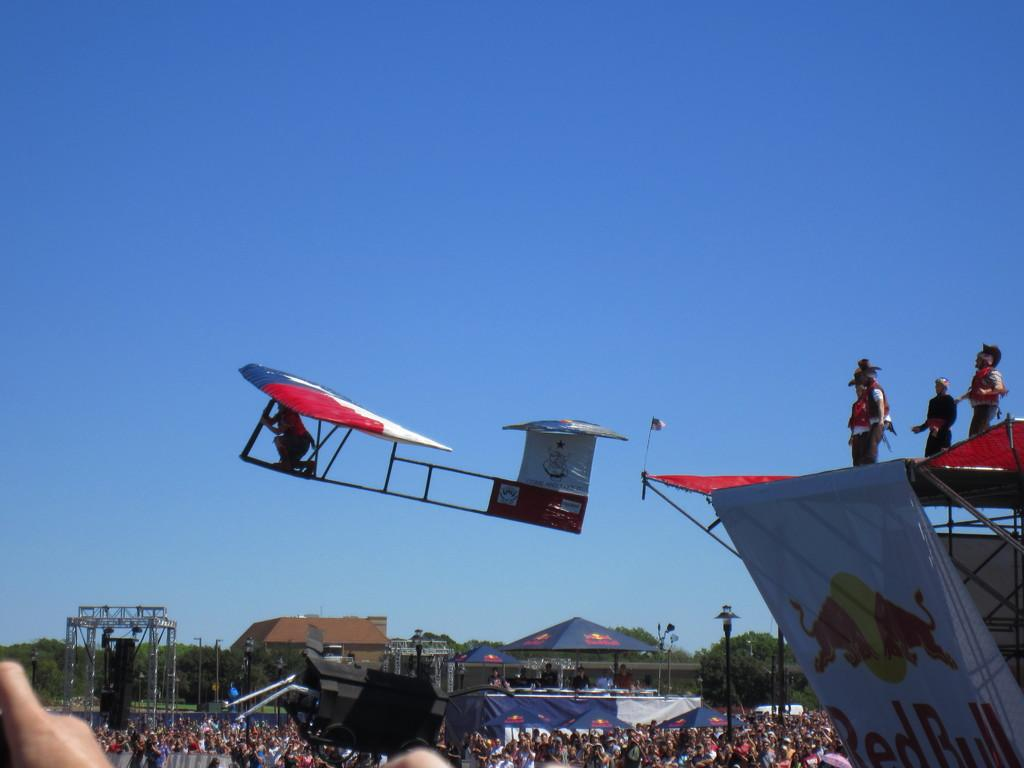Provide a one-sentence caption for the provided image. A few people standing above a banner advertising red bull. 